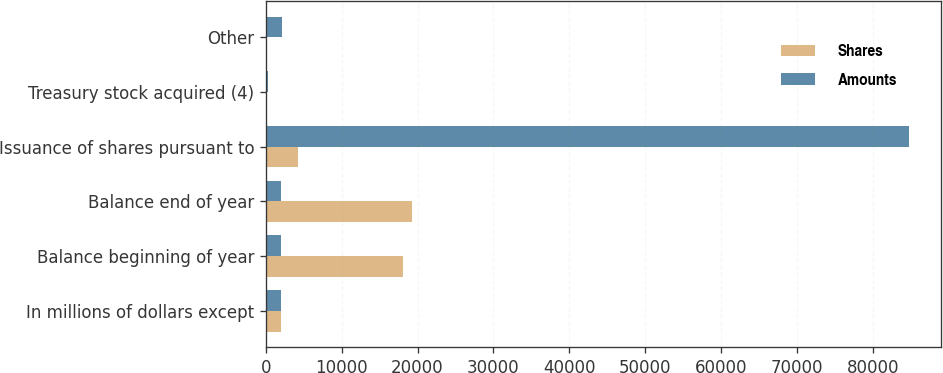Convert chart to OTSL. <chart><loc_0><loc_0><loc_500><loc_500><stacked_bar_chart><ecel><fcel>In millions of dollars except<fcel>Balance beginning of year<fcel>Balance end of year<fcel>Issuance of shares pursuant to<fcel>Treasury stock acquired (4)<fcel>Other<nl><fcel>Shares<fcel>2008<fcel>18062<fcel>19222<fcel>4270<fcel>7<fcel>21<nl><fcel>Amounts<fcel>2008<fcel>2066.5<fcel>2066.5<fcel>84724<fcel>343<fcel>2125<nl></chart> 